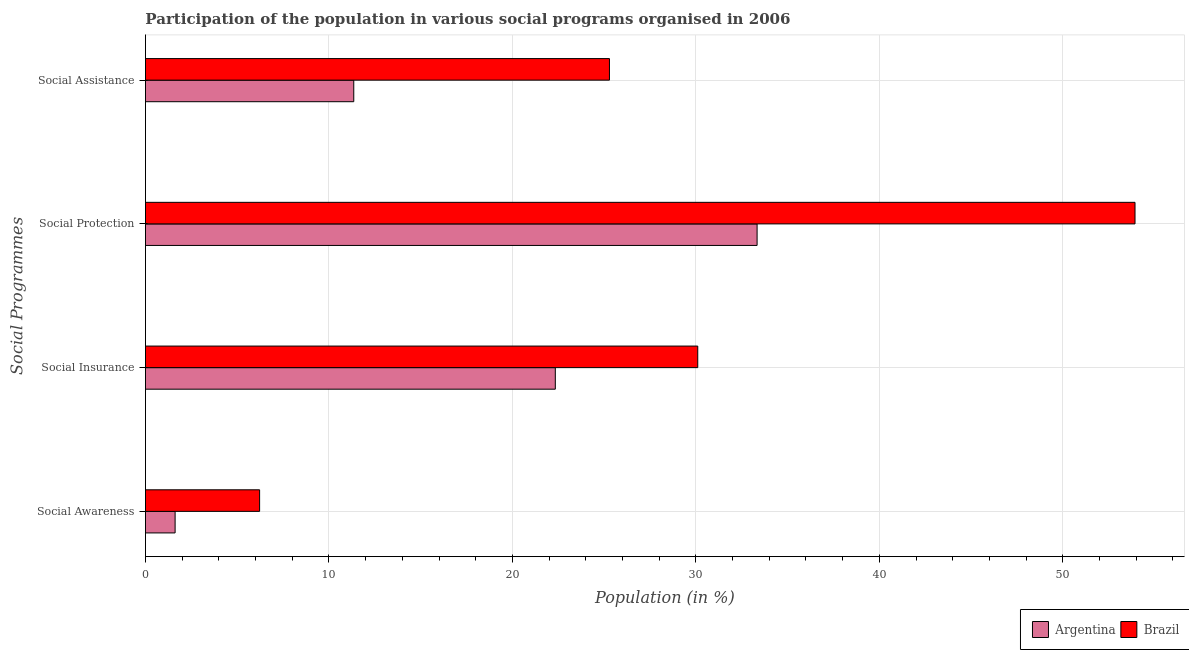How many different coloured bars are there?
Keep it short and to the point. 2. How many groups of bars are there?
Provide a succinct answer. 4. Are the number of bars per tick equal to the number of legend labels?
Offer a terse response. Yes. Are the number of bars on each tick of the Y-axis equal?
Your answer should be very brief. Yes. How many bars are there on the 4th tick from the top?
Your answer should be very brief. 2. How many bars are there on the 2nd tick from the bottom?
Offer a terse response. 2. What is the label of the 1st group of bars from the top?
Keep it short and to the point. Social Assistance. What is the participation of population in social insurance programs in Brazil?
Make the answer very short. 30.1. Across all countries, what is the maximum participation of population in social protection programs?
Provide a short and direct response. 53.93. Across all countries, what is the minimum participation of population in social protection programs?
Offer a terse response. 33.34. In which country was the participation of population in social assistance programs maximum?
Give a very brief answer. Brazil. What is the total participation of population in social insurance programs in the graph?
Ensure brevity in your answer.  52.44. What is the difference between the participation of population in social assistance programs in Argentina and that in Brazil?
Offer a very short reply. -13.93. What is the difference between the participation of population in social awareness programs in Argentina and the participation of population in social insurance programs in Brazil?
Offer a very short reply. -28.48. What is the average participation of population in social assistance programs per country?
Provide a succinct answer. 18.32. What is the difference between the participation of population in social awareness programs and participation of population in social insurance programs in Brazil?
Provide a succinct answer. -23.88. What is the ratio of the participation of population in social insurance programs in Brazil to that in Argentina?
Your answer should be compact. 1.35. Is the participation of population in social assistance programs in Brazil less than that in Argentina?
Make the answer very short. No. What is the difference between the highest and the second highest participation of population in social assistance programs?
Your answer should be compact. 13.93. What is the difference between the highest and the lowest participation of population in social protection programs?
Keep it short and to the point. 20.6. In how many countries, is the participation of population in social protection programs greater than the average participation of population in social protection programs taken over all countries?
Keep it short and to the point. 1. Is the sum of the participation of population in social protection programs in Brazil and Argentina greater than the maximum participation of population in social assistance programs across all countries?
Provide a succinct answer. Yes. Is it the case that in every country, the sum of the participation of population in social assistance programs and participation of population in social awareness programs is greater than the sum of participation of population in social protection programs and participation of population in social insurance programs?
Provide a short and direct response. No. What does the 2nd bar from the bottom in Social Awareness represents?
Provide a succinct answer. Brazil. How many bars are there?
Your answer should be compact. 8. What is the difference between two consecutive major ticks on the X-axis?
Make the answer very short. 10. Where does the legend appear in the graph?
Give a very brief answer. Bottom right. What is the title of the graph?
Provide a short and direct response. Participation of the population in various social programs organised in 2006. What is the label or title of the X-axis?
Make the answer very short. Population (in %). What is the label or title of the Y-axis?
Provide a succinct answer. Social Programmes. What is the Population (in %) in Argentina in Social Awareness?
Ensure brevity in your answer.  1.62. What is the Population (in %) in Brazil in Social Awareness?
Your response must be concise. 6.22. What is the Population (in %) of Argentina in Social Insurance?
Keep it short and to the point. 22.34. What is the Population (in %) in Brazil in Social Insurance?
Ensure brevity in your answer.  30.1. What is the Population (in %) in Argentina in Social Protection?
Offer a very short reply. 33.34. What is the Population (in %) in Brazil in Social Protection?
Offer a terse response. 53.93. What is the Population (in %) in Argentina in Social Assistance?
Provide a short and direct response. 11.35. What is the Population (in %) in Brazil in Social Assistance?
Your response must be concise. 25.29. Across all Social Programmes, what is the maximum Population (in %) of Argentina?
Ensure brevity in your answer.  33.34. Across all Social Programmes, what is the maximum Population (in %) of Brazil?
Offer a very short reply. 53.93. Across all Social Programmes, what is the minimum Population (in %) in Argentina?
Provide a succinct answer. 1.62. Across all Social Programmes, what is the minimum Population (in %) in Brazil?
Provide a short and direct response. 6.22. What is the total Population (in %) in Argentina in the graph?
Offer a terse response. 68.64. What is the total Population (in %) in Brazil in the graph?
Provide a short and direct response. 115.54. What is the difference between the Population (in %) in Argentina in Social Awareness and that in Social Insurance?
Your response must be concise. -20.72. What is the difference between the Population (in %) in Brazil in Social Awareness and that in Social Insurance?
Ensure brevity in your answer.  -23.88. What is the difference between the Population (in %) in Argentina in Social Awareness and that in Social Protection?
Your answer should be compact. -31.72. What is the difference between the Population (in %) in Brazil in Social Awareness and that in Social Protection?
Your response must be concise. -47.71. What is the difference between the Population (in %) of Argentina in Social Awareness and that in Social Assistance?
Your answer should be very brief. -9.74. What is the difference between the Population (in %) in Brazil in Social Awareness and that in Social Assistance?
Ensure brevity in your answer.  -19.07. What is the difference between the Population (in %) of Argentina in Social Insurance and that in Social Protection?
Ensure brevity in your answer.  -11. What is the difference between the Population (in %) in Brazil in Social Insurance and that in Social Protection?
Provide a succinct answer. -23.83. What is the difference between the Population (in %) in Argentina in Social Insurance and that in Social Assistance?
Your answer should be compact. 10.98. What is the difference between the Population (in %) in Brazil in Social Insurance and that in Social Assistance?
Provide a succinct answer. 4.81. What is the difference between the Population (in %) of Argentina in Social Protection and that in Social Assistance?
Give a very brief answer. 21.98. What is the difference between the Population (in %) of Brazil in Social Protection and that in Social Assistance?
Offer a terse response. 28.64. What is the difference between the Population (in %) in Argentina in Social Awareness and the Population (in %) in Brazil in Social Insurance?
Your answer should be compact. -28.48. What is the difference between the Population (in %) in Argentina in Social Awareness and the Population (in %) in Brazil in Social Protection?
Give a very brief answer. -52.32. What is the difference between the Population (in %) of Argentina in Social Awareness and the Population (in %) of Brazil in Social Assistance?
Your answer should be compact. -23.67. What is the difference between the Population (in %) in Argentina in Social Insurance and the Population (in %) in Brazil in Social Protection?
Give a very brief answer. -31.59. What is the difference between the Population (in %) of Argentina in Social Insurance and the Population (in %) of Brazil in Social Assistance?
Offer a terse response. -2.95. What is the difference between the Population (in %) in Argentina in Social Protection and the Population (in %) in Brazil in Social Assistance?
Give a very brief answer. 8.05. What is the average Population (in %) in Argentina per Social Programmes?
Ensure brevity in your answer.  17.16. What is the average Population (in %) in Brazil per Social Programmes?
Provide a succinct answer. 28.89. What is the difference between the Population (in %) in Argentina and Population (in %) in Brazil in Social Awareness?
Provide a short and direct response. -4.6. What is the difference between the Population (in %) of Argentina and Population (in %) of Brazil in Social Insurance?
Give a very brief answer. -7.76. What is the difference between the Population (in %) in Argentina and Population (in %) in Brazil in Social Protection?
Your answer should be compact. -20.6. What is the difference between the Population (in %) of Argentina and Population (in %) of Brazil in Social Assistance?
Provide a succinct answer. -13.93. What is the ratio of the Population (in %) in Argentina in Social Awareness to that in Social Insurance?
Give a very brief answer. 0.07. What is the ratio of the Population (in %) in Brazil in Social Awareness to that in Social Insurance?
Provide a succinct answer. 0.21. What is the ratio of the Population (in %) of Argentina in Social Awareness to that in Social Protection?
Your answer should be very brief. 0.05. What is the ratio of the Population (in %) in Brazil in Social Awareness to that in Social Protection?
Your answer should be compact. 0.12. What is the ratio of the Population (in %) of Argentina in Social Awareness to that in Social Assistance?
Your answer should be very brief. 0.14. What is the ratio of the Population (in %) in Brazil in Social Awareness to that in Social Assistance?
Provide a succinct answer. 0.25. What is the ratio of the Population (in %) of Argentina in Social Insurance to that in Social Protection?
Provide a short and direct response. 0.67. What is the ratio of the Population (in %) in Brazil in Social Insurance to that in Social Protection?
Your answer should be compact. 0.56. What is the ratio of the Population (in %) in Argentina in Social Insurance to that in Social Assistance?
Your answer should be very brief. 1.97. What is the ratio of the Population (in %) in Brazil in Social Insurance to that in Social Assistance?
Give a very brief answer. 1.19. What is the ratio of the Population (in %) in Argentina in Social Protection to that in Social Assistance?
Keep it short and to the point. 2.94. What is the ratio of the Population (in %) of Brazil in Social Protection to that in Social Assistance?
Make the answer very short. 2.13. What is the difference between the highest and the second highest Population (in %) of Argentina?
Provide a short and direct response. 11. What is the difference between the highest and the second highest Population (in %) of Brazil?
Make the answer very short. 23.83. What is the difference between the highest and the lowest Population (in %) in Argentina?
Give a very brief answer. 31.72. What is the difference between the highest and the lowest Population (in %) of Brazil?
Your answer should be compact. 47.71. 